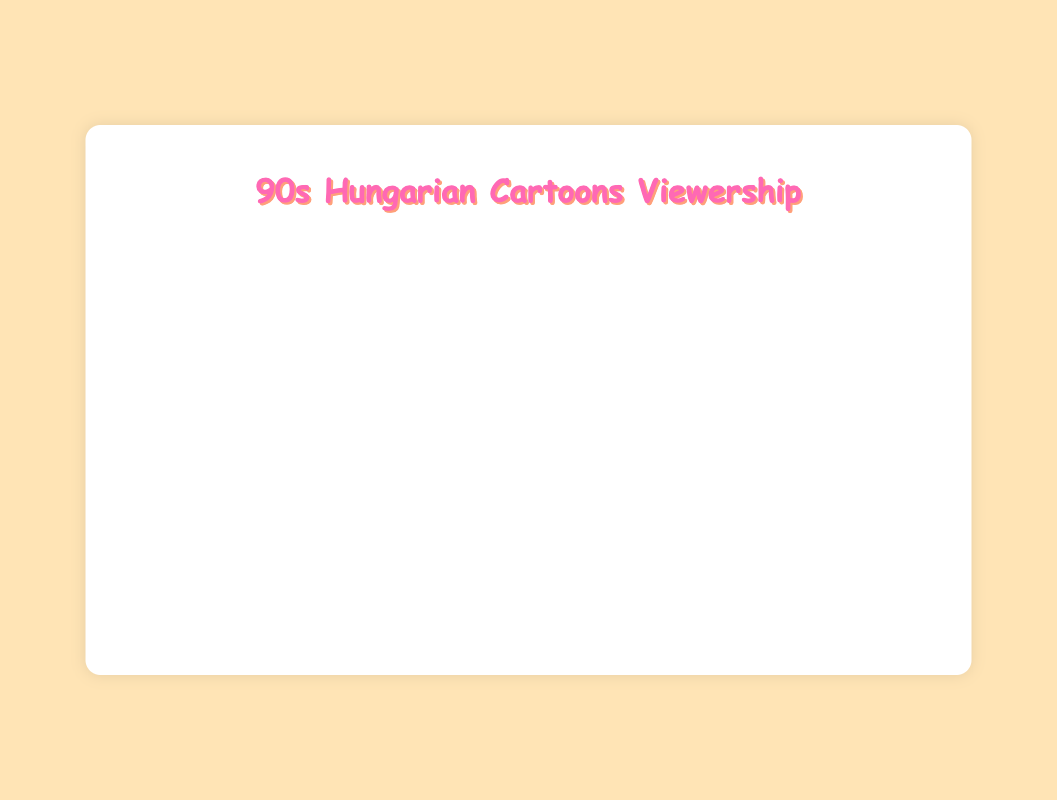What is the title of the chart? The title of the chart is typically found at the top and visually distinct in size or color, making it easy to identify.
Answer: 90s Hungarian Cartoons Viewership How many cartoons are represented on this chart? Each data point on a scatter plot represents a cartoon, and we can count all the individual points to find the total number.
Answer: 10 Which cartoon has the highest monthly viewership hours? The data point that is the highest on the y-axis represents the cartoon with the highest monthly viewership hours.
Answer: The Smurfs What is the monthly viewership of "Captain Tenkes" compared to "Vuk"? Locate the points representing "Captain Tenkes" and "Vuk" on the scatter plot and compare their y-values.
Answer: 78000 for "Captain Tenkes" and 135000 for "Vuk" What decade saw the release of the cartoon with the lowest viewership? Identify the cartoon with the lowest viewership by locating the lowest point on the y-axis, and then find its x-value to determine the decade.
Answer: 1960s (Captain Tenkes) Which cartoon has the closest release date to "The Smurfs"? Find the point representing "The Smurfs" on the scatter plot and look for the point nearest in terms of x-value.
Answer: Vuk What is the average viewership of cartoons released in the 1980s? Sum the viewership hours of cartoons released in the 1980s and divide by the number of cartoons from that decade.
Answer: (140000 + 135000 + 110000) / 3 = 128333.33 Is there an observable trend in viewership hours relative to the release dates? Analyze the trend line on the scatter plot to see if viewership hours increase or decrease over time.
Answer: No, there's no clear trend How does "Pom Pom Tales" compare in viewership hours to the average viewership of all cartoons listed? Calculate the average viewership of all cartoons, then compare it to the viewership of "Pom Pom Tales." Average: (120000 + 95000 + 140000 + 85000 + 78000 + 110000 + 135000 + 92000 + 130000 + 87000) / 10 = 106700. Pom Pom Tales = 110000.
Answer: 110000 vs 106700 What is the range of viewership hours for the cartoons? Identify the highest and lowest y-values on the scatter plot, then subtract the lowest from the highest to find the range. Highest: 140000 (The Smurfs), Lowest: 78000 (Captain Tenkes).
Answer: 140000 - 78000 = 62000 